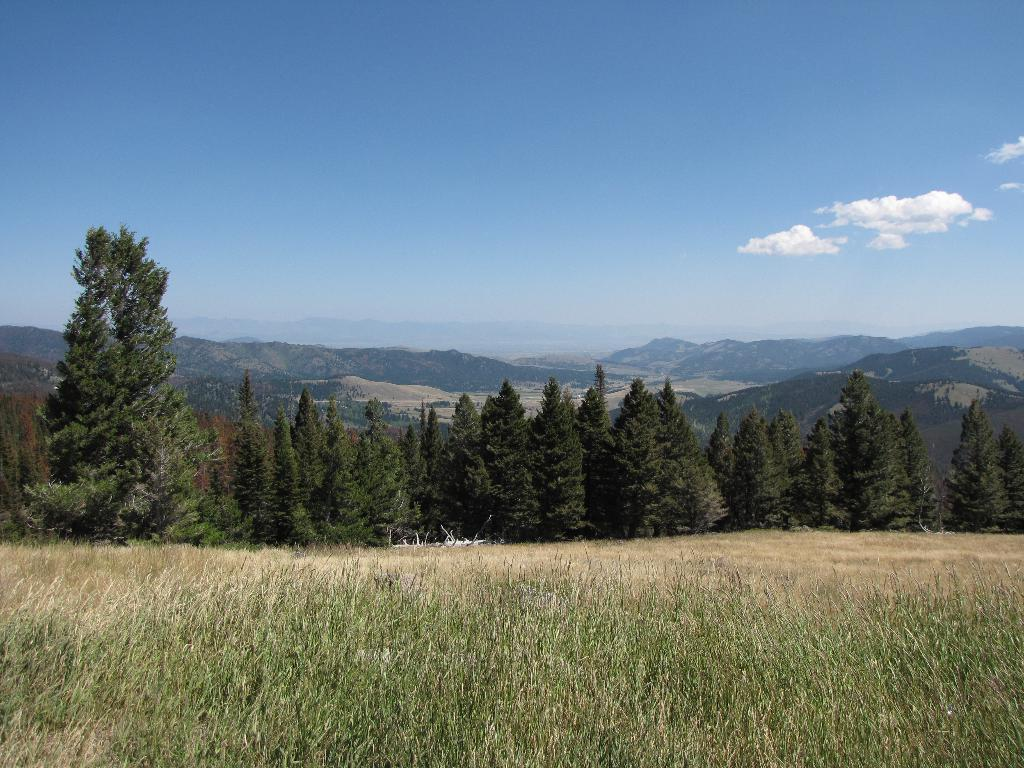What type of vegetation can be seen in the image? There are trees in the image. What is the color of the trees? The trees are green. What else can be seen in the image besides trees? There is grass in the image. What is the color of the grass? The grass is green. What can be seen in the background of the image? There are mountains in the background of the image. What is the color of the sky in the image? The sky is blue and white. What type of cup is being used to hold the force in the image? There is no mention of a cup, force, or any related objects in the image. 